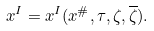<formula> <loc_0><loc_0><loc_500><loc_500>x ^ { I } = x ^ { I } ( x ^ { \# } , \tau , \zeta , \overline { \zeta } ) .</formula> 